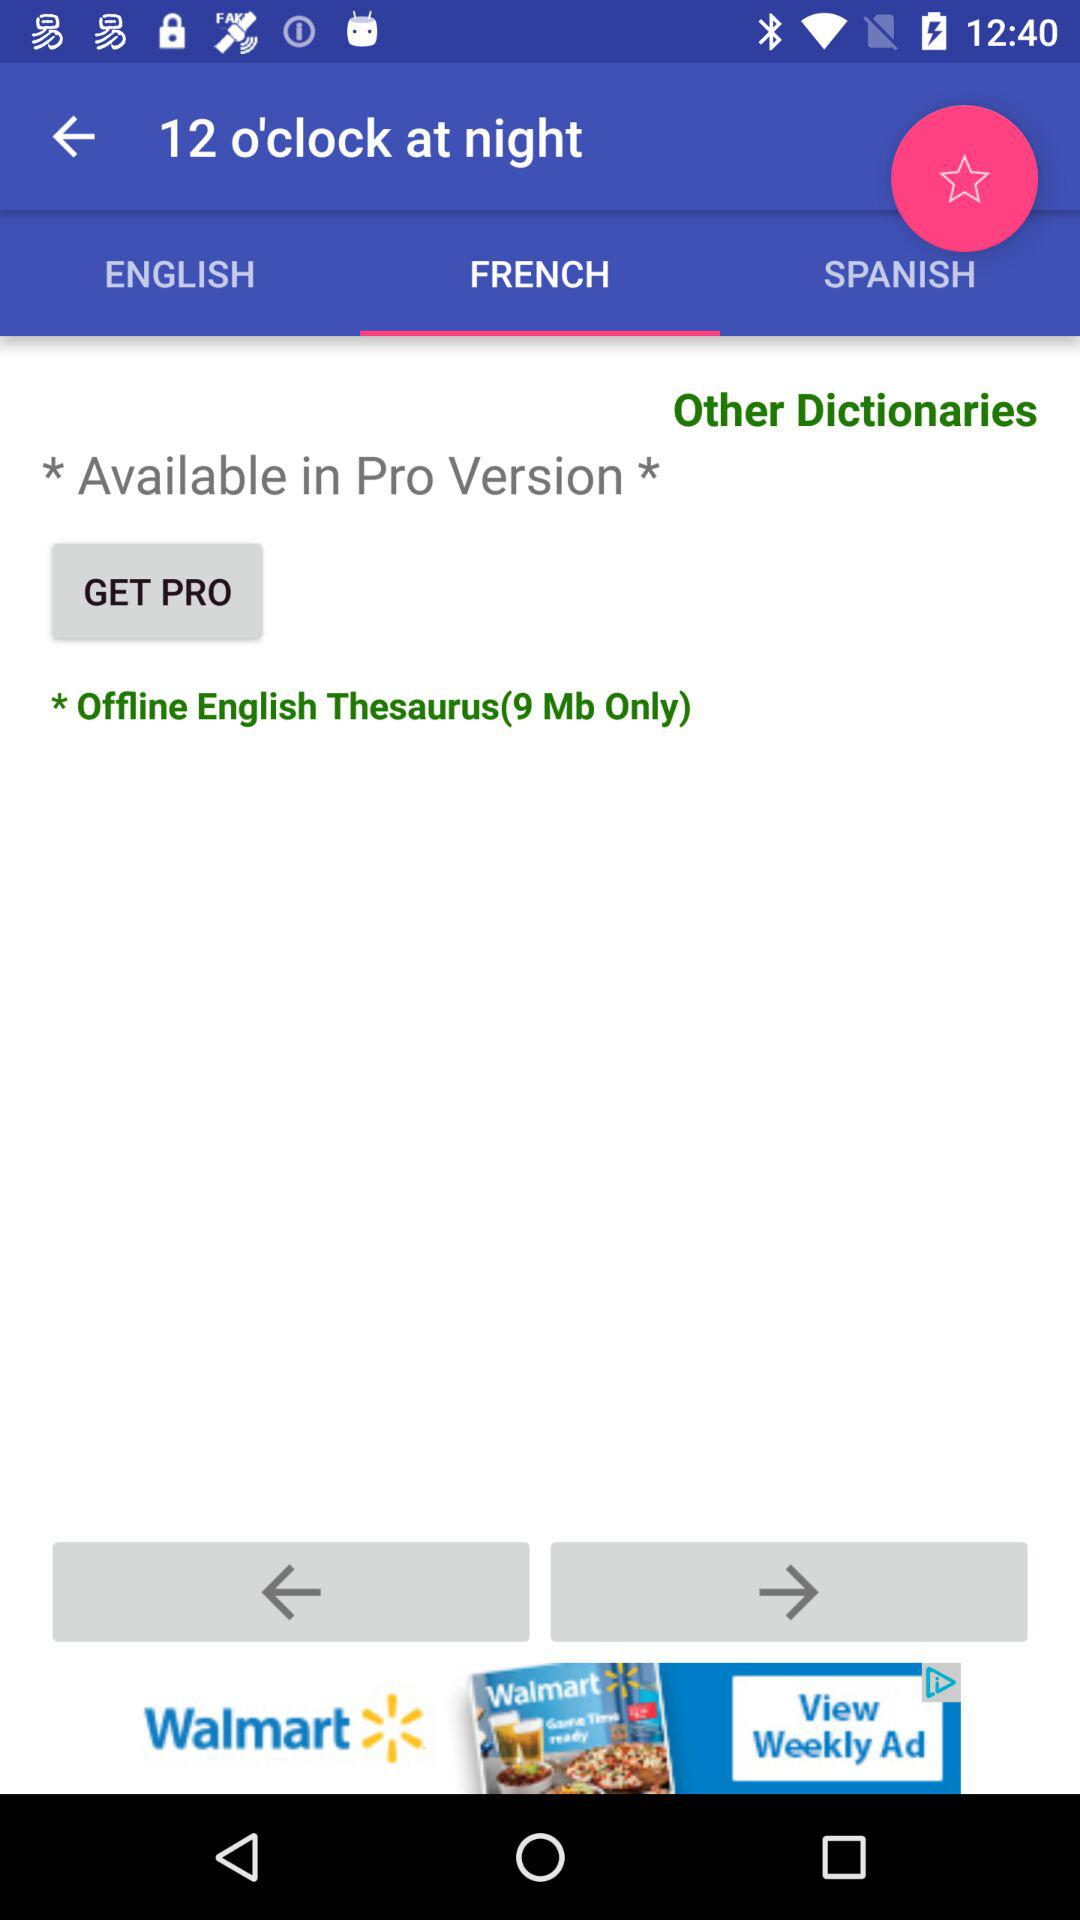What is the size of the "Offline English Thesaurus"? The size is 9 Mb. 